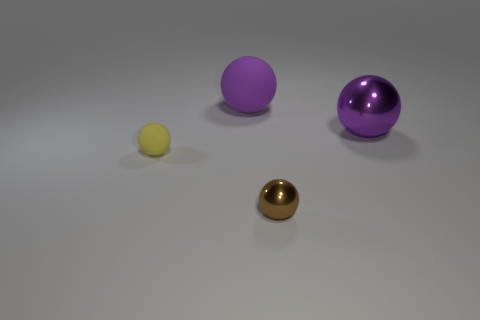What number of other things are the same color as the big matte ball?
Provide a succinct answer. 1. Is the shape of the large purple metallic thing the same as the small yellow matte thing?
Offer a terse response. Yes. What is the size of the other brown thing that is the same shape as the tiny matte thing?
Provide a short and direct response. Small. There is another large ball that is the same color as the large matte sphere; what material is it?
Offer a terse response. Metal. What number of large shiny spheres have the same color as the big rubber sphere?
Make the answer very short. 1. There is a object that is the same material as the brown ball; what is its size?
Offer a very short reply. Large. There is a yellow thing that is the same shape as the small brown metallic object; what is it made of?
Your answer should be very brief. Rubber. The brown object that is the same size as the yellow thing is what shape?
Give a very brief answer. Sphere. Is there a big green object of the same shape as the yellow rubber object?
Provide a succinct answer. No. There is a matte thing that is on the right side of the tiny sphere that is on the left side of the purple matte ball; what is its shape?
Provide a short and direct response. Sphere. 